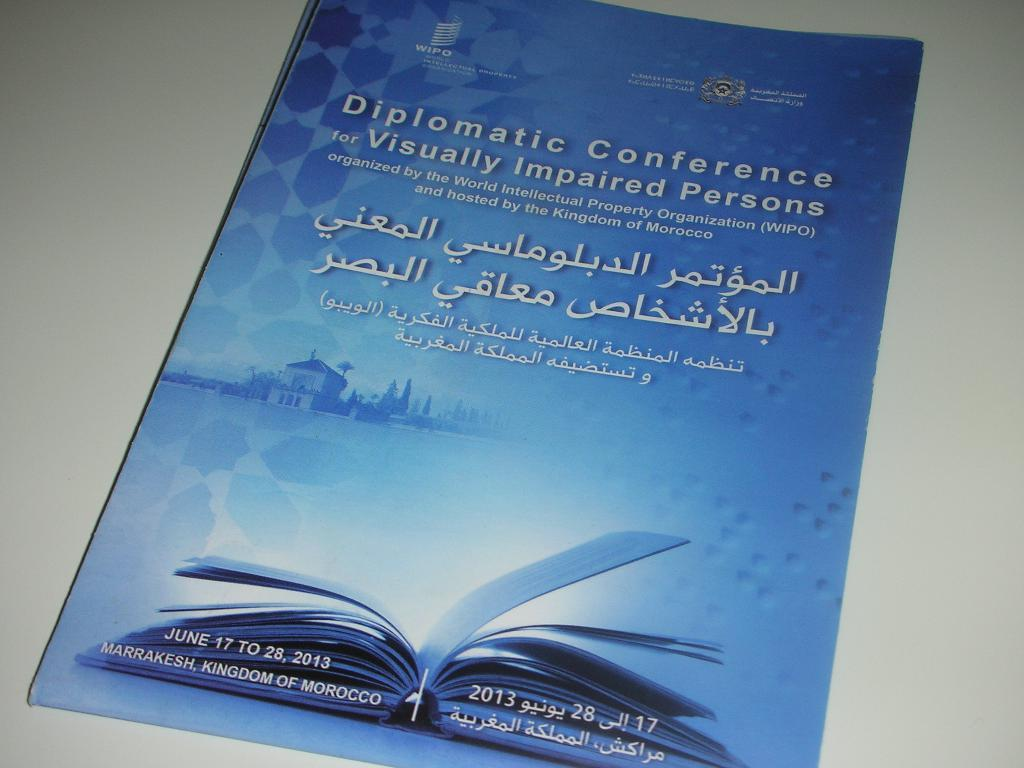<image>
Provide a brief description of the given image. A book is entitled "Diplomatic Conference for Visually Impaired Persons." 